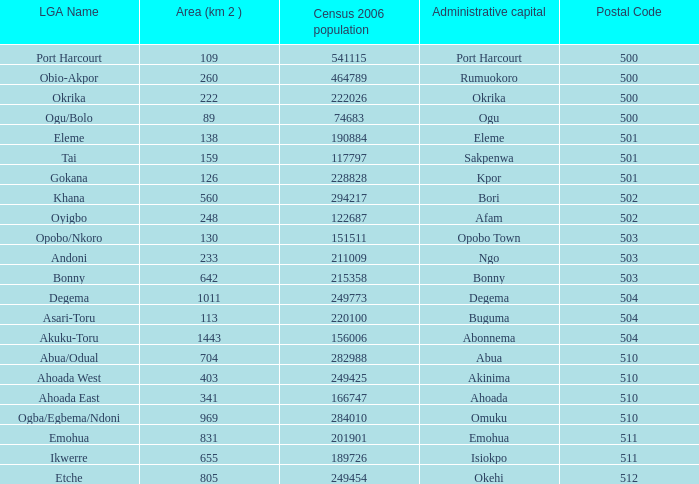What is the zip code for the administrative capital in bori? 502.0. 